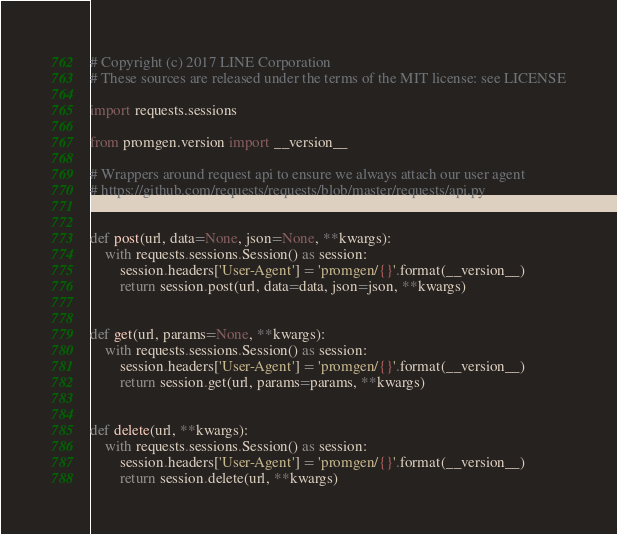<code> <loc_0><loc_0><loc_500><loc_500><_Python_># Copyright (c) 2017 LINE Corporation
# These sources are released under the terms of the MIT license: see LICENSE

import requests.sessions

from promgen.version import __version__

# Wrappers around request api to ensure we always attach our user agent
# https://github.com/requests/requests/blob/master/requests/api.py


def post(url, data=None, json=None, **kwargs):
    with requests.sessions.Session() as session:
        session.headers['User-Agent'] = 'promgen/{}'.format(__version__)
        return session.post(url, data=data, json=json, **kwargs)


def get(url, params=None, **kwargs):
    with requests.sessions.Session() as session:
        session.headers['User-Agent'] = 'promgen/{}'.format(__version__)
        return session.get(url, params=params, **kwargs)


def delete(url, **kwargs):
    with requests.sessions.Session() as session:
        session.headers['User-Agent'] = 'promgen/{}'.format(__version__)
        return session.delete(url, **kwargs)
</code> 